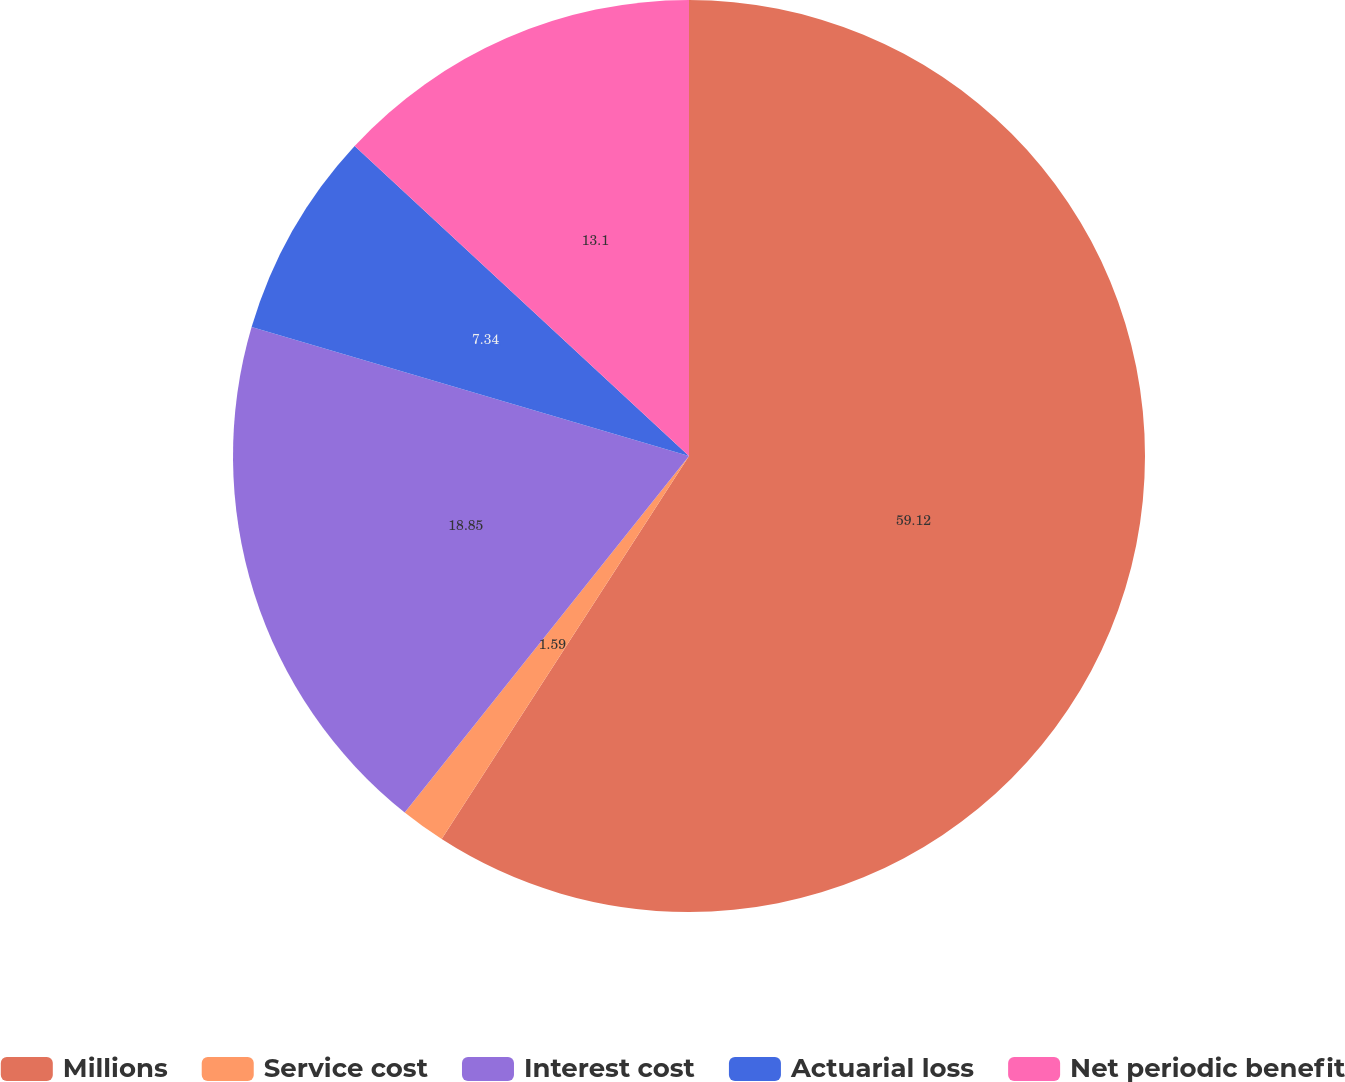Convert chart to OTSL. <chart><loc_0><loc_0><loc_500><loc_500><pie_chart><fcel>Millions<fcel>Service cost<fcel>Interest cost<fcel>Actuarial loss<fcel>Net periodic benefit<nl><fcel>59.13%<fcel>1.59%<fcel>18.85%<fcel>7.34%<fcel>13.1%<nl></chart> 